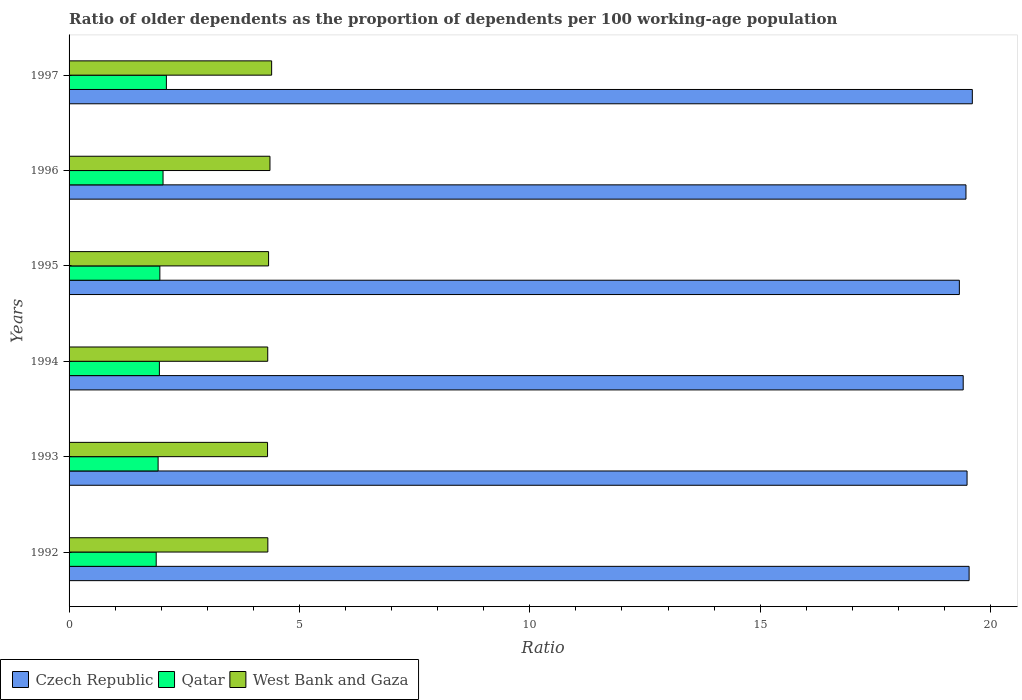How many different coloured bars are there?
Offer a very short reply. 3. Are the number of bars on each tick of the Y-axis equal?
Your answer should be very brief. Yes. In how many cases, is the number of bars for a given year not equal to the number of legend labels?
Your answer should be compact. 0. What is the age dependency ratio(old) in West Bank and Gaza in 1997?
Provide a succinct answer. 4.4. Across all years, what is the maximum age dependency ratio(old) in Czech Republic?
Give a very brief answer. 19.6. Across all years, what is the minimum age dependency ratio(old) in West Bank and Gaza?
Keep it short and to the point. 4.31. In which year was the age dependency ratio(old) in Qatar maximum?
Your answer should be very brief. 1997. What is the total age dependency ratio(old) in Czech Republic in the graph?
Give a very brief answer. 116.82. What is the difference between the age dependency ratio(old) in West Bank and Gaza in 1992 and that in 1993?
Offer a terse response. 0.01. What is the difference between the age dependency ratio(old) in West Bank and Gaza in 1992 and the age dependency ratio(old) in Czech Republic in 1996?
Your answer should be very brief. -15.15. What is the average age dependency ratio(old) in West Bank and Gaza per year?
Your answer should be very brief. 4.34. In the year 1996, what is the difference between the age dependency ratio(old) in West Bank and Gaza and age dependency ratio(old) in Czech Republic?
Make the answer very short. -15.11. What is the ratio of the age dependency ratio(old) in West Bank and Gaza in 1994 to that in 1996?
Keep it short and to the point. 0.99. Is the difference between the age dependency ratio(old) in West Bank and Gaza in 1992 and 1997 greater than the difference between the age dependency ratio(old) in Czech Republic in 1992 and 1997?
Keep it short and to the point. No. What is the difference between the highest and the second highest age dependency ratio(old) in Czech Republic?
Make the answer very short. 0.07. What is the difference between the highest and the lowest age dependency ratio(old) in West Bank and Gaza?
Make the answer very short. 0.09. What does the 1st bar from the top in 1993 represents?
Your answer should be very brief. West Bank and Gaza. What does the 2nd bar from the bottom in 1994 represents?
Ensure brevity in your answer.  Qatar. Are all the bars in the graph horizontal?
Give a very brief answer. Yes. How many years are there in the graph?
Give a very brief answer. 6. What is the difference between two consecutive major ticks on the X-axis?
Give a very brief answer. 5. Are the values on the major ticks of X-axis written in scientific E-notation?
Keep it short and to the point. No. How many legend labels are there?
Your response must be concise. 3. How are the legend labels stacked?
Ensure brevity in your answer.  Horizontal. What is the title of the graph?
Provide a succinct answer. Ratio of older dependents as the proportion of dependents per 100 working-age population. What is the label or title of the X-axis?
Your answer should be very brief. Ratio. What is the Ratio of Czech Republic in 1992?
Provide a short and direct response. 19.53. What is the Ratio of Qatar in 1992?
Offer a very short reply. 1.89. What is the Ratio of West Bank and Gaza in 1992?
Your answer should be compact. 4.31. What is the Ratio in Czech Republic in 1993?
Keep it short and to the point. 19.49. What is the Ratio in Qatar in 1993?
Provide a succinct answer. 1.93. What is the Ratio in West Bank and Gaza in 1993?
Keep it short and to the point. 4.31. What is the Ratio of Czech Republic in 1994?
Your response must be concise. 19.41. What is the Ratio in Qatar in 1994?
Ensure brevity in your answer.  1.96. What is the Ratio in West Bank and Gaza in 1994?
Give a very brief answer. 4.31. What is the Ratio in Czech Republic in 1995?
Your response must be concise. 19.32. What is the Ratio in Qatar in 1995?
Provide a short and direct response. 1.97. What is the Ratio in West Bank and Gaza in 1995?
Make the answer very short. 4.33. What is the Ratio of Czech Republic in 1996?
Ensure brevity in your answer.  19.47. What is the Ratio of Qatar in 1996?
Give a very brief answer. 2.04. What is the Ratio in West Bank and Gaza in 1996?
Your answer should be very brief. 4.36. What is the Ratio in Czech Republic in 1997?
Offer a terse response. 19.6. What is the Ratio in Qatar in 1997?
Ensure brevity in your answer.  2.11. What is the Ratio of West Bank and Gaza in 1997?
Provide a short and direct response. 4.4. Across all years, what is the maximum Ratio in Czech Republic?
Offer a very short reply. 19.6. Across all years, what is the maximum Ratio of Qatar?
Your response must be concise. 2.11. Across all years, what is the maximum Ratio in West Bank and Gaza?
Keep it short and to the point. 4.4. Across all years, what is the minimum Ratio of Czech Republic?
Offer a very short reply. 19.32. Across all years, what is the minimum Ratio of Qatar?
Offer a very short reply. 1.89. Across all years, what is the minimum Ratio of West Bank and Gaza?
Provide a succinct answer. 4.31. What is the total Ratio in Czech Republic in the graph?
Your response must be concise. 116.82. What is the total Ratio of Qatar in the graph?
Keep it short and to the point. 11.91. What is the total Ratio in West Bank and Gaza in the graph?
Provide a short and direct response. 26.02. What is the difference between the Ratio in Czech Republic in 1992 and that in 1993?
Keep it short and to the point. 0.04. What is the difference between the Ratio in Qatar in 1992 and that in 1993?
Your response must be concise. -0.04. What is the difference between the Ratio in West Bank and Gaza in 1992 and that in 1993?
Provide a short and direct response. 0.01. What is the difference between the Ratio of Czech Republic in 1992 and that in 1994?
Provide a short and direct response. 0.13. What is the difference between the Ratio in Qatar in 1992 and that in 1994?
Give a very brief answer. -0.07. What is the difference between the Ratio in West Bank and Gaza in 1992 and that in 1994?
Provide a succinct answer. 0. What is the difference between the Ratio of Czech Republic in 1992 and that in 1995?
Give a very brief answer. 0.21. What is the difference between the Ratio of Qatar in 1992 and that in 1995?
Offer a very short reply. -0.08. What is the difference between the Ratio of West Bank and Gaza in 1992 and that in 1995?
Offer a very short reply. -0.02. What is the difference between the Ratio in Czech Republic in 1992 and that in 1996?
Offer a very short reply. 0.07. What is the difference between the Ratio in Qatar in 1992 and that in 1996?
Keep it short and to the point. -0.15. What is the difference between the Ratio in West Bank and Gaza in 1992 and that in 1996?
Your answer should be compact. -0.05. What is the difference between the Ratio of Czech Republic in 1992 and that in 1997?
Keep it short and to the point. -0.07. What is the difference between the Ratio in Qatar in 1992 and that in 1997?
Ensure brevity in your answer.  -0.22. What is the difference between the Ratio of West Bank and Gaza in 1992 and that in 1997?
Provide a succinct answer. -0.08. What is the difference between the Ratio of Czech Republic in 1993 and that in 1994?
Make the answer very short. 0.08. What is the difference between the Ratio in Qatar in 1993 and that in 1994?
Offer a very short reply. -0.03. What is the difference between the Ratio in West Bank and Gaza in 1993 and that in 1994?
Offer a terse response. -0. What is the difference between the Ratio in Czech Republic in 1993 and that in 1995?
Your response must be concise. 0.17. What is the difference between the Ratio of Qatar in 1993 and that in 1995?
Your answer should be compact. -0.04. What is the difference between the Ratio of West Bank and Gaza in 1993 and that in 1995?
Your answer should be very brief. -0.02. What is the difference between the Ratio of Czech Republic in 1993 and that in 1996?
Ensure brevity in your answer.  0.02. What is the difference between the Ratio in Qatar in 1993 and that in 1996?
Make the answer very short. -0.11. What is the difference between the Ratio of West Bank and Gaza in 1993 and that in 1996?
Keep it short and to the point. -0.05. What is the difference between the Ratio in Czech Republic in 1993 and that in 1997?
Your answer should be very brief. -0.11. What is the difference between the Ratio of Qatar in 1993 and that in 1997?
Ensure brevity in your answer.  -0.18. What is the difference between the Ratio of West Bank and Gaza in 1993 and that in 1997?
Keep it short and to the point. -0.09. What is the difference between the Ratio of Czech Republic in 1994 and that in 1995?
Provide a short and direct response. 0.08. What is the difference between the Ratio of Qatar in 1994 and that in 1995?
Offer a terse response. -0.01. What is the difference between the Ratio of West Bank and Gaza in 1994 and that in 1995?
Keep it short and to the point. -0.02. What is the difference between the Ratio of Czech Republic in 1994 and that in 1996?
Give a very brief answer. -0.06. What is the difference between the Ratio in Qatar in 1994 and that in 1996?
Your answer should be compact. -0.08. What is the difference between the Ratio of West Bank and Gaza in 1994 and that in 1996?
Offer a terse response. -0.05. What is the difference between the Ratio in Czech Republic in 1994 and that in 1997?
Ensure brevity in your answer.  -0.2. What is the difference between the Ratio in Qatar in 1994 and that in 1997?
Provide a short and direct response. -0.15. What is the difference between the Ratio of West Bank and Gaza in 1994 and that in 1997?
Offer a very short reply. -0.08. What is the difference between the Ratio in Czech Republic in 1995 and that in 1996?
Keep it short and to the point. -0.14. What is the difference between the Ratio in Qatar in 1995 and that in 1996?
Give a very brief answer. -0.07. What is the difference between the Ratio of West Bank and Gaza in 1995 and that in 1996?
Provide a succinct answer. -0.03. What is the difference between the Ratio of Czech Republic in 1995 and that in 1997?
Your answer should be very brief. -0.28. What is the difference between the Ratio in Qatar in 1995 and that in 1997?
Provide a succinct answer. -0.14. What is the difference between the Ratio in West Bank and Gaza in 1995 and that in 1997?
Offer a terse response. -0.07. What is the difference between the Ratio in Czech Republic in 1996 and that in 1997?
Make the answer very short. -0.14. What is the difference between the Ratio of Qatar in 1996 and that in 1997?
Give a very brief answer. -0.07. What is the difference between the Ratio in West Bank and Gaza in 1996 and that in 1997?
Your answer should be compact. -0.04. What is the difference between the Ratio in Czech Republic in 1992 and the Ratio in Qatar in 1993?
Make the answer very short. 17.6. What is the difference between the Ratio in Czech Republic in 1992 and the Ratio in West Bank and Gaza in 1993?
Offer a very short reply. 15.23. What is the difference between the Ratio in Qatar in 1992 and the Ratio in West Bank and Gaza in 1993?
Offer a very short reply. -2.42. What is the difference between the Ratio of Czech Republic in 1992 and the Ratio of Qatar in 1994?
Keep it short and to the point. 17.57. What is the difference between the Ratio of Czech Republic in 1992 and the Ratio of West Bank and Gaza in 1994?
Provide a short and direct response. 15.22. What is the difference between the Ratio of Qatar in 1992 and the Ratio of West Bank and Gaza in 1994?
Offer a terse response. -2.42. What is the difference between the Ratio of Czech Republic in 1992 and the Ratio of Qatar in 1995?
Provide a succinct answer. 17.56. What is the difference between the Ratio of Czech Republic in 1992 and the Ratio of West Bank and Gaza in 1995?
Make the answer very short. 15.2. What is the difference between the Ratio in Qatar in 1992 and the Ratio in West Bank and Gaza in 1995?
Keep it short and to the point. -2.44. What is the difference between the Ratio in Czech Republic in 1992 and the Ratio in Qatar in 1996?
Your answer should be compact. 17.49. What is the difference between the Ratio in Czech Republic in 1992 and the Ratio in West Bank and Gaza in 1996?
Offer a terse response. 15.17. What is the difference between the Ratio of Qatar in 1992 and the Ratio of West Bank and Gaza in 1996?
Provide a succinct answer. -2.47. What is the difference between the Ratio of Czech Republic in 1992 and the Ratio of Qatar in 1997?
Make the answer very short. 17.42. What is the difference between the Ratio in Czech Republic in 1992 and the Ratio in West Bank and Gaza in 1997?
Your answer should be very brief. 15.14. What is the difference between the Ratio of Qatar in 1992 and the Ratio of West Bank and Gaza in 1997?
Give a very brief answer. -2.51. What is the difference between the Ratio of Czech Republic in 1993 and the Ratio of Qatar in 1994?
Offer a very short reply. 17.53. What is the difference between the Ratio in Czech Republic in 1993 and the Ratio in West Bank and Gaza in 1994?
Give a very brief answer. 15.18. What is the difference between the Ratio in Qatar in 1993 and the Ratio in West Bank and Gaza in 1994?
Offer a very short reply. -2.38. What is the difference between the Ratio of Czech Republic in 1993 and the Ratio of Qatar in 1995?
Provide a succinct answer. 17.52. What is the difference between the Ratio of Czech Republic in 1993 and the Ratio of West Bank and Gaza in 1995?
Your response must be concise. 15.16. What is the difference between the Ratio of Qatar in 1993 and the Ratio of West Bank and Gaza in 1995?
Your answer should be very brief. -2.4. What is the difference between the Ratio in Czech Republic in 1993 and the Ratio in Qatar in 1996?
Your answer should be compact. 17.45. What is the difference between the Ratio in Czech Republic in 1993 and the Ratio in West Bank and Gaza in 1996?
Make the answer very short. 15.13. What is the difference between the Ratio in Qatar in 1993 and the Ratio in West Bank and Gaza in 1996?
Your response must be concise. -2.43. What is the difference between the Ratio of Czech Republic in 1993 and the Ratio of Qatar in 1997?
Ensure brevity in your answer.  17.38. What is the difference between the Ratio in Czech Republic in 1993 and the Ratio in West Bank and Gaza in 1997?
Give a very brief answer. 15.09. What is the difference between the Ratio of Qatar in 1993 and the Ratio of West Bank and Gaza in 1997?
Give a very brief answer. -2.46. What is the difference between the Ratio in Czech Republic in 1994 and the Ratio in Qatar in 1995?
Ensure brevity in your answer.  17.44. What is the difference between the Ratio of Czech Republic in 1994 and the Ratio of West Bank and Gaza in 1995?
Give a very brief answer. 15.08. What is the difference between the Ratio in Qatar in 1994 and the Ratio in West Bank and Gaza in 1995?
Ensure brevity in your answer.  -2.37. What is the difference between the Ratio of Czech Republic in 1994 and the Ratio of Qatar in 1996?
Your response must be concise. 17.37. What is the difference between the Ratio of Czech Republic in 1994 and the Ratio of West Bank and Gaza in 1996?
Your response must be concise. 15.05. What is the difference between the Ratio of Qatar in 1994 and the Ratio of West Bank and Gaza in 1996?
Your answer should be compact. -2.4. What is the difference between the Ratio in Czech Republic in 1994 and the Ratio in Qatar in 1997?
Your response must be concise. 17.29. What is the difference between the Ratio of Czech Republic in 1994 and the Ratio of West Bank and Gaza in 1997?
Give a very brief answer. 15.01. What is the difference between the Ratio in Qatar in 1994 and the Ratio in West Bank and Gaza in 1997?
Keep it short and to the point. -2.44. What is the difference between the Ratio of Czech Republic in 1995 and the Ratio of Qatar in 1996?
Make the answer very short. 17.28. What is the difference between the Ratio in Czech Republic in 1995 and the Ratio in West Bank and Gaza in 1996?
Give a very brief answer. 14.96. What is the difference between the Ratio in Qatar in 1995 and the Ratio in West Bank and Gaza in 1996?
Your answer should be very brief. -2.39. What is the difference between the Ratio of Czech Republic in 1995 and the Ratio of Qatar in 1997?
Provide a short and direct response. 17.21. What is the difference between the Ratio in Czech Republic in 1995 and the Ratio in West Bank and Gaza in 1997?
Ensure brevity in your answer.  14.93. What is the difference between the Ratio in Qatar in 1995 and the Ratio in West Bank and Gaza in 1997?
Your answer should be very brief. -2.43. What is the difference between the Ratio in Czech Republic in 1996 and the Ratio in Qatar in 1997?
Keep it short and to the point. 17.35. What is the difference between the Ratio in Czech Republic in 1996 and the Ratio in West Bank and Gaza in 1997?
Give a very brief answer. 15.07. What is the difference between the Ratio of Qatar in 1996 and the Ratio of West Bank and Gaza in 1997?
Your answer should be very brief. -2.36. What is the average Ratio of Czech Republic per year?
Offer a very short reply. 19.47. What is the average Ratio in Qatar per year?
Your response must be concise. 1.98. What is the average Ratio of West Bank and Gaza per year?
Offer a terse response. 4.34. In the year 1992, what is the difference between the Ratio of Czech Republic and Ratio of Qatar?
Your answer should be very brief. 17.64. In the year 1992, what is the difference between the Ratio of Czech Republic and Ratio of West Bank and Gaza?
Offer a very short reply. 15.22. In the year 1992, what is the difference between the Ratio in Qatar and Ratio in West Bank and Gaza?
Your answer should be very brief. -2.42. In the year 1993, what is the difference between the Ratio of Czech Republic and Ratio of Qatar?
Keep it short and to the point. 17.56. In the year 1993, what is the difference between the Ratio in Czech Republic and Ratio in West Bank and Gaza?
Keep it short and to the point. 15.18. In the year 1993, what is the difference between the Ratio of Qatar and Ratio of West Bank and Gaza?
Offer a very short reply. -2.38. In the year 1994, what is the difference between the Ratio of Czech Republic and Ratio of Qatar?
Keep it short and to the point. 17.45. In the year 1994, what is the difference between the Ratio in Czech Republic and Ratio in West Bank and Gaza?
Provide a short and direct response. 15.09. In the year 1994, what is the difference between the Ratio in Qatar and Ratio in West Bank and Gaza?
Make the answer very short. -2.35. In the year 1995, what is the difference between the Ratio in Czech Republic and Ratio in Qatar?
Keep it short and to the point. 17.35. In the year 1995, what is the difference between the Ratio of Czech Republic and Ratio of West Bank and Gaza?
Ensure brevity in your answer.  14.99. In the year 1995, what is the difference between the Ratio in Qatar and Ratio in West Bank and Gaza?
Offer a very short reply. -2.36. In the year 1996, what is the difference between the Ratio of Czech Republic and Ratio of Qatar?
Keep it short and to the point. 17.43. In the year 1996, what is the difference between the Ratio of Czech Republic and Ratio of West Bank and Gaza?
Your answer should be very brief. 15.11. In the year 1996, what is the difference between the Ratio in Qatar and Ratio in West Bank and Gaza?
Provide a succinct answer. -2.32. In the year 1997, what is the difference between the Ratio of Czech Republic and Ratio of Qatar?
Ensure brevity in your answer.  17.49. In the year 1997, what is the difference between the Ratio in Czech Republic and Ratio in West Bank and Gaza?
Ensure brevity in your answer.  15.21. In the year 1997, what is the difference between the Ratio in Qatar and Ratio in West Bank and Gaza?
Provide a succinct answer. -2.28. What is the ratio of the Ratio of Qatar in 1992 to that in 1993?
Your answer should be compact. 0.98. What is the ratio of the Ratio in Czech Republic in 1992 to that in 1994?
Provide a short and direct response. 1.01. What is the ratio of the Ratio of Qatar in 1992 to that in 1994?
Provide a short and direct response. 0.96. What is the ratio of the Ratio in West Bank and Gaza in 1992 to that in 1994?
Make the answer very short. 1. What is the ratio of the Ratio in Czech Republic in 1992 to that in 1995?
Your response must be concise. 1.01. What is the ratio of the Ratio of Qatar in 1992 to that in 1995?
Your answer should be compact. 0.96. What is the ratio of the Ratio of Czech Republic in 1992 to that in 1996?
Ensure brevity in your answer.  1. What is the ratio of the Ratio in Qatar in 1992 to that in 1996?
Keep it short and to the point. 0.93. What is the ratio of the Ratio in Czech Republic in 1992 to that in 1997?
Your answer should be very brief. 1. What is the ratio of the Ratio of Qatar in 1992 to that in 1997?
Keep it short and to the point. 0.9. What is the ratio of the Ratio in West Bank and Gaza in 1992 to that in 1997?
Keep it short and to the point. 0.98. What is the ratio of the Ratio in Czech Republic in 1993 to that in 1994?
Your response must be concise. 1. What is the ratio of the Ratio of Qatar in 1993 to that in 1994?
Give a very brief answer. 0.99. What is the ratio of the Ratio of Czech Republic in 1993 to that in 1995?
Your response must be concise. 1.01. What is the ratio of the Ratio of Qatar in 1993 to that in 1995?
Your answer should be compact. 0.98. What is the ratio of the Ratio of West Bank and Gaza in 1993 to that in 1995?
Make the answer very short. 0.99. What is the ratio of the Ratio in Qatar in 1993 to that in 1996?
Your response must be concise. 0.95. What is the ratio of the Ratio of Czech Republic in 1993 to that in 1997?
Offer a terse response. 0.99. What is the ratio of the Ratio in Qatar in 1993 to that in 1997?
Give a very brief answer. 0.91. What is the ratio of the Ratio of West Bank and Gaza in 1993 to that in 1997?
Your response must be concise. 0.98. What is the ratio of the Ratio in Czech Republic in 1994 to that in 1995?
Ensure brevity in your answer.  1. What is the ratio of the Ratio of Qatar in 1994 to that in 1995?
Offer a terse response. 0.99. What is the ratio of the Ratio of West Bank and Gaza in 1994 to that in 1995?
Ensure brevity in your answer.  1. What is the ratio of the Ratio in Czech Republic in 1994 to that in 1996?
Your response must be concise. 1. What is the ratio of the Ratio of Qatar in 1994 to that in 1996?
Provide a short and direct response. 0.96. What is the ratio of the Ratio of West Bank and Gaza in 1994 to that in 1996?
Provide a succinct answer. 0.99. What is the ratio of the Ratio in Czech Republic in 1994 to that in 1997?
Offer a terse response. 0.99. What is the ratio of the Ratio of Qatar in 1994 to that in 1997?
Offer a terse response. 0.93. What is the ratio of the Ratio in West Bank and Gaza in 1994 to that in 1997?
Offer a terse response. 0.98. What is the ratio of the Ratio of Qatar in 1995 to that in 1996?
Your answer should be very brief. 0.97. What is the ratio of the Ratio of West Bank and Gaza in 1995 to that in 1996?
Your answer should be compact. 0.99. What is the ratio of the Ratio in Czech Republic in 1995 to that in 1997?
Offer a terse response. 0.99. What is the ratio of the Ratio of Qatar in 1995 to that in 1997?
Offer a very short reply. 0.93. What is the ratio of the Ratio of West Bank and Gaza in 1995 to that in 1997?
Give a very brief answer. 0.98. What is the ratio of the Ratio in Qatar in 1996 to that in 1997?
Make the answer very short. 0.97. What is the ratio of the Ratio in West Bank and Gaza in 1996 to that in 1997?
Give a very brief answer. 0.99. What is the difference between the highest and the second highest Ratio in Czech Republic?
Provide a short and direct response. 0.07. What is the difference between the highest and the second highest Ratio of Qatar?
Your response must be concise. 0.07. What is the difference between the highest and the second highest Ratio of West Bank and Gaza?
Your response must be concise. 0.04. What is the difference between the highest and the lowest Ratio of Czech Republic?
Your answer should be very brief. 0.28. What is the difference between the highest and the lowest Ratio of Qatar?
Offer a very short reply. 0.22. What is the difference between the highest and the lowest Ratio in West Bank and Gaza?
Keep it short and to the point. 0.09. 